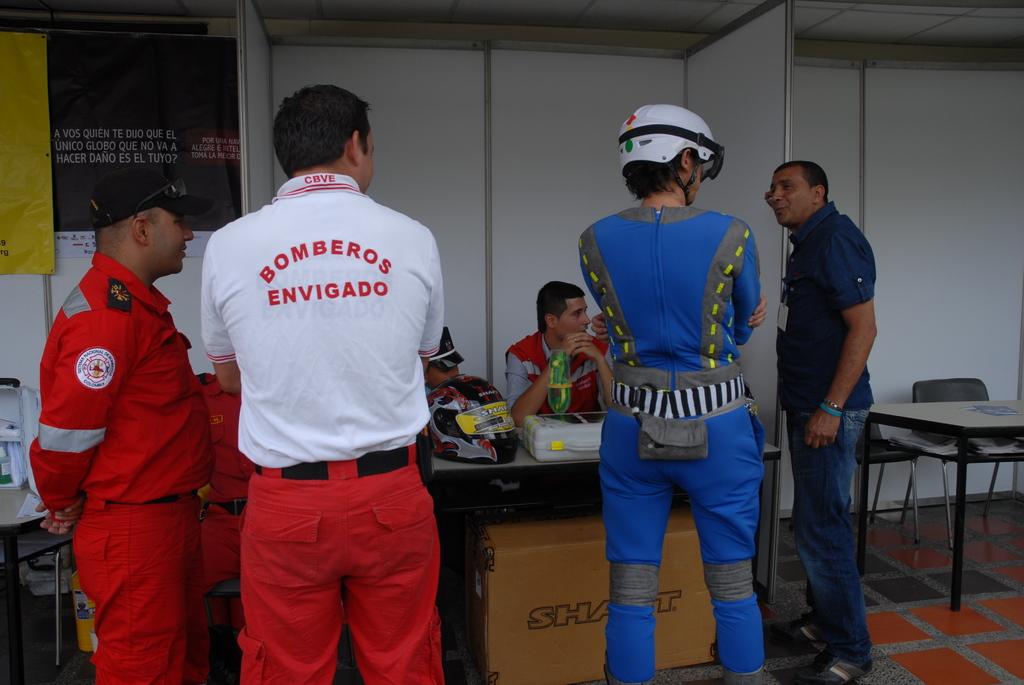What does the white shirt say?
Offer a terse response. Bomberos envigado. 